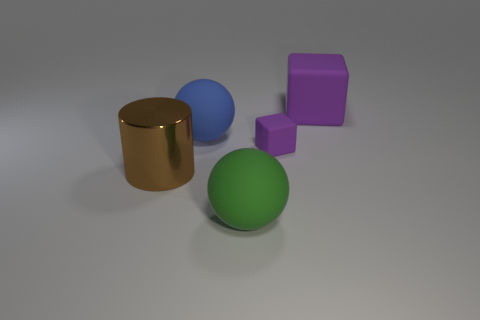Add 3 tiny purple blocks. How many objects exist? 8 Subtract 0 cyan cylinders. How many objects are left? 5 Subtract all blocks. How many objects are left? 3 Subtract all small yellow matte things. Subtract all matte things. How many objects are left? 1 Add 5 metallic objects. How many metallic objects are left? 6 Add 4 purple rubber things. How many purple rubber things exist? 6 